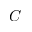Convert formula to latex. <formula><loc_0><loc_0><loc_500><loc_500>C</formula> 